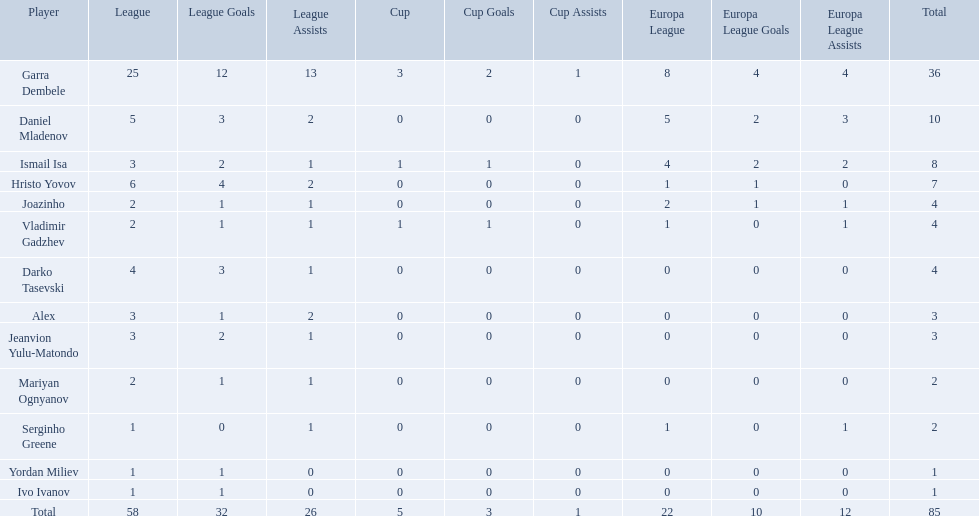What league is 2? 2, 2, 2. Which cup is less than 1? 0, 0. Which total is 2? 2. Who is the player? Mariyan Ognyanov. 